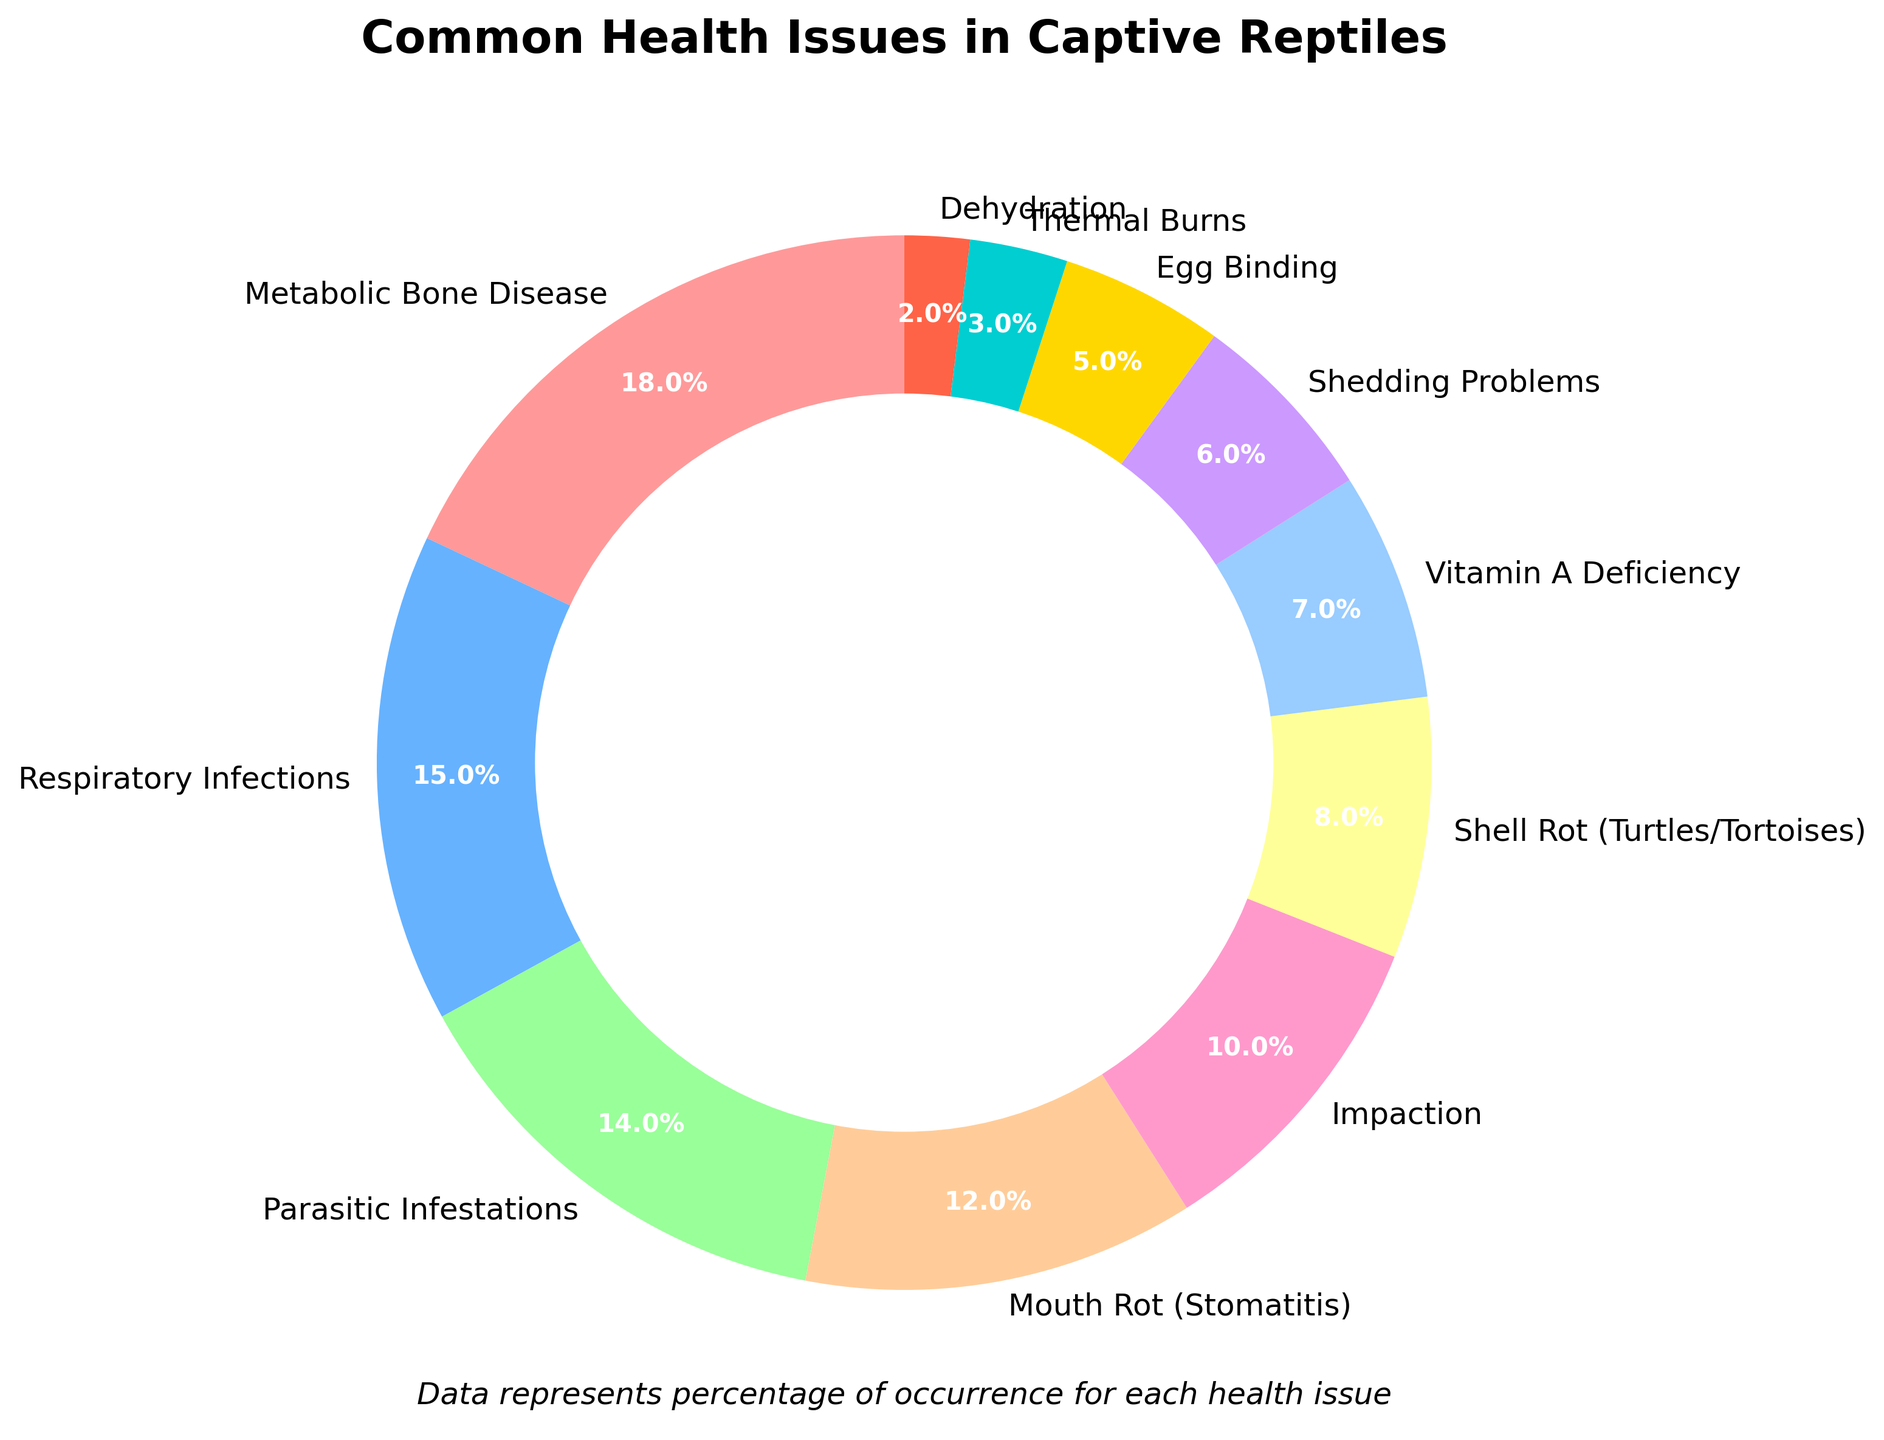What's the most common health issue in captive reptiles? The pie chart shows different health issues with their respective percentages. The largest segment on the chart represents the most common issue.
Answer: Metabolic Bone Disease Which health issue has a higher percentage: Parasitic Infestations or Mouth Rot (Stomatitis)? By comparing the segments labeled "Parasitic Infestations" and "Mouth Rot (Stomatitis)" on the pie chart, we see that Parasitic Infestations are at 14% and Mouth Rot (Stomatitis) at 12%.
Answer: Parasitic Infestations What is the combined percentage of Impaction and Thermal Burns? Add the percentages for Impaction (10%) and Thermal Burns (3%). 10 + 3 equals 13%.
Answer: 13% Is Vitamin A Deficiency more common than Shedding Problems? Looking at the pie chart sections, Vitamin A Deficiency is marked as 7% while Shedding Problems are marked as 6%. Vitamin A Deficiency has a higher percentage.
Answer: Yes What is the percentage difference between Respiratory Infections and Egg Binding? Subtract the percentage of Egg Binding (5%) from Respiratory Infections (15%). The difference is 15 - 5 = 10%.
Answer: 10% Which health issue is represented by the yellow segment on the pie chart? The yellow segment in the chart represents the Shell Rot (Turtles/Tortoises) health issue.
Answer: Shell Rot (Turtles/Tortoises) What is the total percentage of the three least common health issues? Sum the percentages of the three smallest segments: Thermal Burns (3%), Dehydration (2%), and Egg Binding (5%). The total is 3 + 2 + 5 = 10%.
Answer: 10% Are there any health issues that are equally common? The segments on the pie chart each have unique percentage values, indicating no two issues have the same percentage.
Answer: No Out of the listed health issues, how many have a percentage of 10% or higher? Identify and count all segments with 10% or higher: Metabolic Bone Disease (18%), Respiratory Infections (15%), Parasitic Infestations (14%), Mouth Rot (Stomatitis) (12%), and Impaction (10%). There are 5 such issues.
Answer: 5 